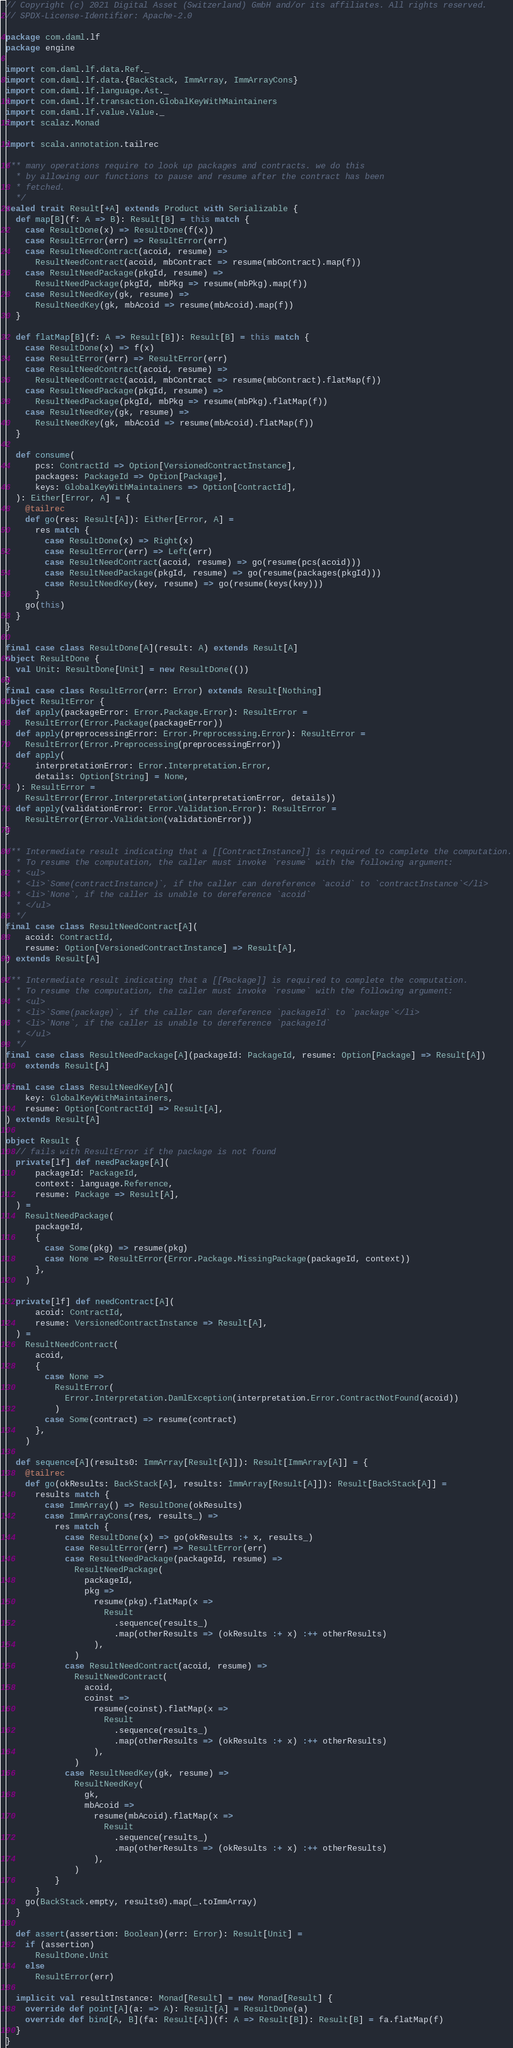Convert code to text. <code><loc_0><loc_0><loc_500><loc_500><_Scala_>// Copyright (c) 2021 Digital Asset (Switzerland) GmbH and/or its affiliates. All rights reserved.
// SPDX-License-Identifier: Apache-2.0

package com.daml.lf
package engine

import com.daml.lf.data.Ref._
import com.daml.lf.data.{BackStack, ImmArray, ImmArrayCons}
import com.daml.lf.language.Ast._
import com.daml.lf.transaction.GlobalKeyWithMaintainers
import com.daml.lf.value.Value._
import scalaz.Monad

import scala.annotation.tailrec

/** many operations require to look up packages and contracts. we do this
  * by allowing our functions to pause and resume after the contract has been
  * fetched.
  */
sealed trait Result[+A] extends Product with Serializable {
  def map[B](f: A => B): Result[B] = this match {
    case ResultDone(x) => ResultDone(f(x))
    case ResultError(err) => ResultError(err)
    case ResultNeedContract(acoid, resume) =>
      ResultNeedContract(acoid, mbContract => resume(mbContract).map(f))
    case ResultNeedPackage(pkgId, resume) =>
      ResultNeedPackage(pkgId, mbPkg => resume(mbPkg).map(f))
    case ResultNeedKey(gk, resume) =>
      ResultNeedKey(gk, mbAcoid => resume(mbAcoid).map(f))
  }

  def flatMap[B](f: A => Result[B]): Result[B] = this match {
    case ResultDone(x) => f(x)
    case ResultError(err) => ResultError(err)
    case ResultNeedContract(acoid, resume) =>
      ResultNeedContract(acoid, mbContract => resume(mbContract).flatMap(f))
    case ResultNeedPackage(pkgId, resume) =>
      ResultNeedPackage(pkgId, mbPkg => resume(mbPkg).flatMap(f))
    case ResultNeedKey(gk, resume) =>
      ResultNeedKey(gk, mbAcoid => resume(mbAcoid).flatMap(f))
  }

  def consume(
      pcs: ContractId => Option[VersionedContractInstance],
      packages: PackageId => Option[Package],
      keys: GlobalKeyWithMaintainers => Option[ContractId],
  ): Either[Error, A] = {
    @tailrec
    def go(res: Result[A]): Either[Error, A] =
      res match {
        case ResultDone(x) => Right(x)
        case ResultError(err) => Left(err)
        case ResultNeedContract(acoid, resume) => go(resume(pcs(acoid)))
        case ResultNeedPackage(pkgId, resume) => go(resume(packages(pkgId)))
        case ResultNeedKey(key, resume) => go(resume(keys(key)))
      }
    go(this)
  }
}

final case class ResultDone[A](result: A) extends Result[A]
object ResultDone {
  val Unit: ResultDone[Unit] = new ResultDone(())
}
final case class ResultError(err: Error) extends Result[Nothing]
object ResultError {
  def apply(packageError: Error.Package.Error): ResultError =
    ResultError(Error.Package(packageError))
  def apply(preprocessingError: Error.Preprocessing.Error): ResultError =
    ResultError(Error.Preprocessing(preprocessingError))
  def apply(
      interpretationError: Error.Interpretation.Error,
      details: Option[String] = None,
  ): ResultError =
    ResultError(Error.Interpretation(interpretationError, details))
  def apply(validationError: Error.Validation.Error): ResultError =
    ResultError(Error.Validation(validationError))
}

/** Intermediate result indicating that a [[ContractInstance]] is required to complete the computation.
  * To resume the computation, the caller must invoke `resume` with the following argument:
  * <ul>
  * <li>`Some(contractInstance)`, if the caller can dereference `acoid` to `contractInstance`</li>
  * <li>`None`, if the caller is unable to dereference `acoid`
  * </ul>
  */
final case class ResultNeedContract[A](
    acoid: ContractId,
    resume: Option[VersionedContractInstance] => Result[A],
) extends Result[A]

/** Intermediate result indicating that a [[Package]] is required to complete the computation.
  * To resume the computation, the caller must invoke `resume` with the following argument:
  * <ul>
  * <li>`Some(package)`, if the caller can dereference `packageId` to `package`</li>
  * <li>`None`, if the caller is unable to dereference `packageId`
  * </ul>
  */
final case class ResultNeedPackage[A](packageId: PackageId, resume: Option[Package] => Result[A])
    extends Result[A]

final case class ResultNeedKey[A](
    key: GlobalKeyWithMaintainers,
    resume: Option[ContractId] => Result[A],
) extends Result[A]

object Result {
  // fails with ResultError if the package is not found
  private[lf] def needPackage[A](
      packageId: PackageId,
      context: language.Reference,
      resume: Package => Result[A],
  ) =
    ResultNeedPackage(
      packageId,
      {
        case Some(pkg) => resume(pkg)
        case None => ResultError(Error.Package.MissingPackage(packageId, context))
      },
    )

  private[lf] def needContract[A](
      acoid: ContractId,
      resume: VersionedContractInstance => Result[A],
  ) =
    ResultNeedContract(
      acoid,
      {
        case None =>
          ResultError(
            Error.Interpretation.DamlException(interpretation.Error.ContractNotFound(acoid))
          )
        case Some(contract) => resume(contract)
      },
    )

  def sequence[A](results0: ImmArray[Result[A]]): Result[ImmArray[A]] = {
    @tailrec
    def go(okResults: BackStack[A], results: ImmArray[Result[A]]): Result[BackStack[A]] =
      results match {
        case ImmArray() => ResultDone(okResults)
        case ImmArrayCons(res, results_) =>
          res match {
            case ResultDone(x) => go(okResults :+ x, results_)
            case ResultError(err) => ResultError(err)
            case ResultNeedPackage(packageId, resume) =>
              ResultNeedPackage(
                packageId,
                pkg =>
                  resume(pkg).flatMap(x =>
                    Result
                      .sequence(results_)
                      .map(otherResults => (okResults :+ x) :++ otherResults)
                  ),
              )
            case ResultNeedContract(acoid, resume) =>
              ResultNeedContract(
                acoid,
                coinst =>
                  resume(coinst).flatMap(x =>
                    Result
                      .sequence(results_)
                      .map(otherResults => (okResults :+ x) :++ otherResults)
                  ),
              )
            case ResultNeedKey(gk, resume) =>
              ResultNeedKey(
                gk,
                mbAcoid =>
                  resume(mbAcoid).flatMap(x =>
                    Result
                      .sequence(results_)
                      .map(otherResults => (okResults :+ x) :++ otherResults)
                  ),
              )
          }
      }
    go(BackStack.empty, results0).map(_.toImmArray)
  }

  def assert(assertion: Boolean)(err: Error): Result[Unit] =
    if (assertion)
      ResultDone.Unit
    else
      ResultError(err)

  implicit val resultInstance: Monad[Result] = new Monad[Result] {
    override def point[A](a: => A): Result[A] = ResultDone(a)
    override def bind[A, B](fa: Result[A])(f: A => Result[B]): Result[B] = fa.flatMap(f)
  }
}
</code> 